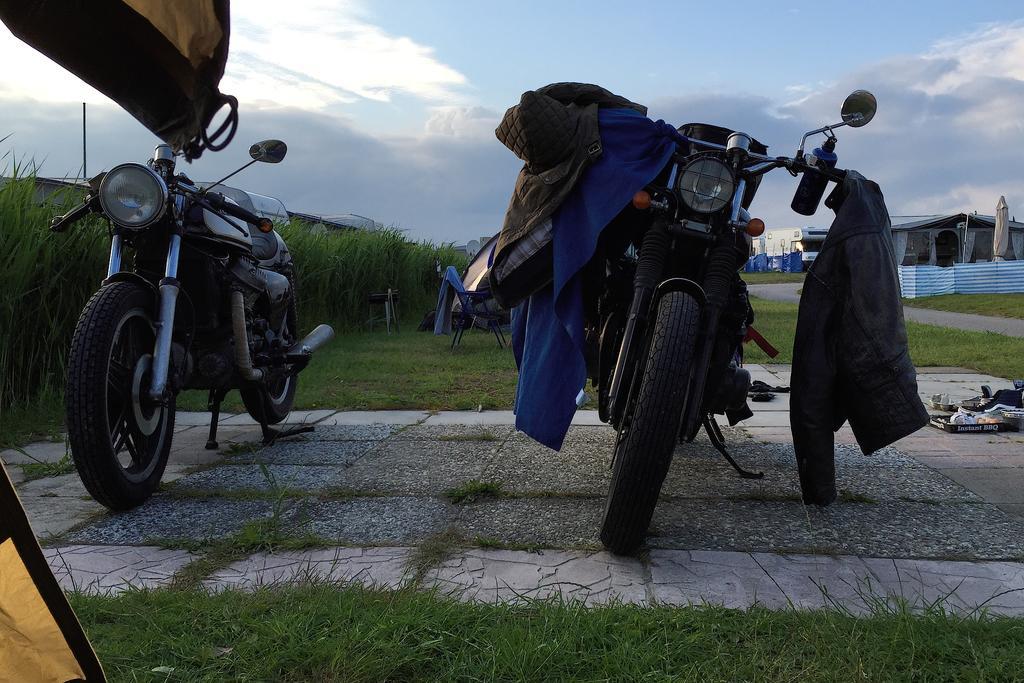Could you give a brief overview of what you see in this image? In this image, we can see some grass and bikes. There is a chair in the middle of the image. There are clothes on bike. There is a shed on the right side of the image. There are clouds in the sky. 